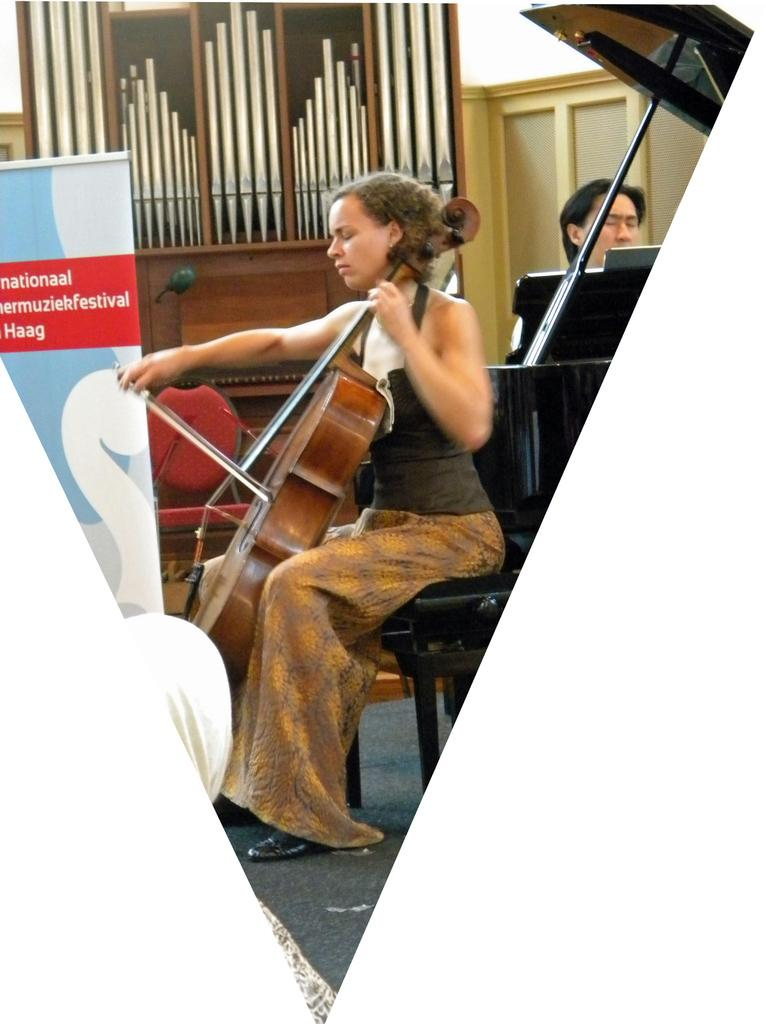Who is the main subject in the image? There is a woman in the image. What is the woman doing in the image? The woman is sitting on a chair and playing a guitar. What can be seen beneath the woman's feet in the image? There is a floor visible in the image. What is present in the background of the image? There is a hoarding in the image. Can you see any cushions on the chair the woman is sitting on in the image? There is no mention of cushions on the chair in the provided facts, so we cannot determine their presence from the image. Is there a lake visible in the image? There is no lake present in the image; it features a woman sitting on a chair and playing a guitar. 